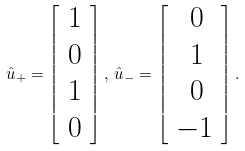Convert formula to latex. <formula><loc_0><loc_0><loc_500><loc_500>\hat { u } _ { + } = \left [ \begin{array} { c } 1 \\ 0 \\ 1 \\ 0 \end{array} \right ] , \, \hat { u } _ { - } = \left [ \begin{array} { c } \, 0 \\ \, 1 \\ \, 0 \\ - 1 \end{array} \right ] .</formula> 